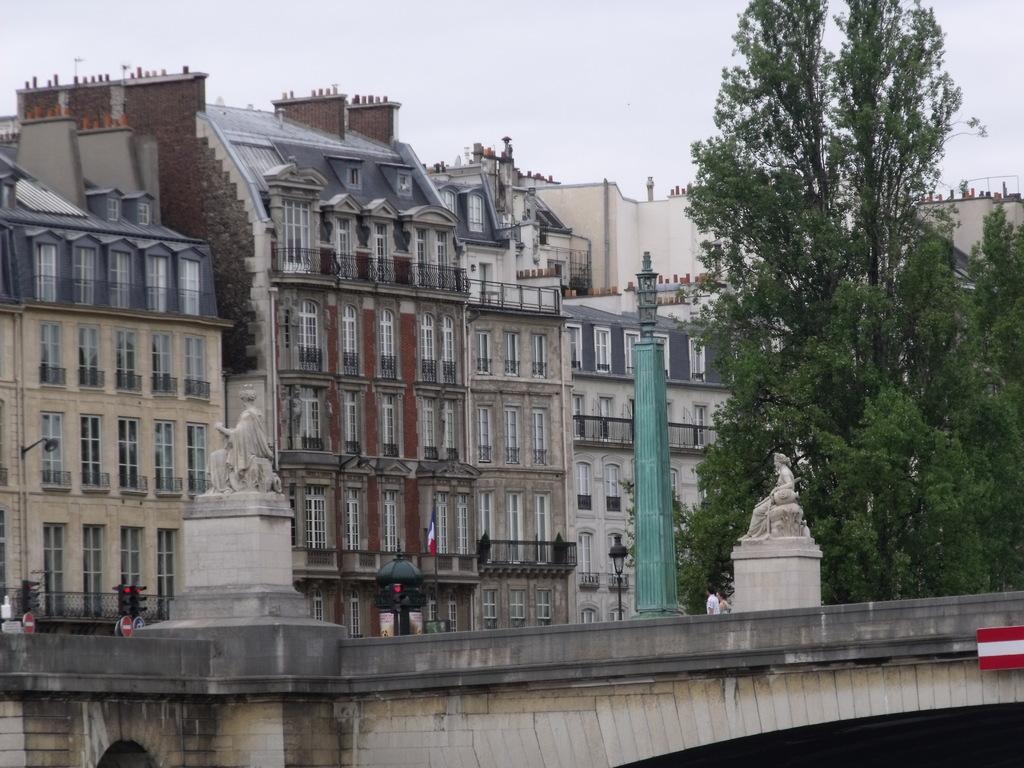Describe this image in one or two sentences. In this image we can see buildings, pillar, street lights, statues, trees, bridge, traffic signals, persons and sky. 